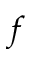Convert formula to latex. <formula><loc_0><loc_0><loc_500><loc_500>f</formula> 